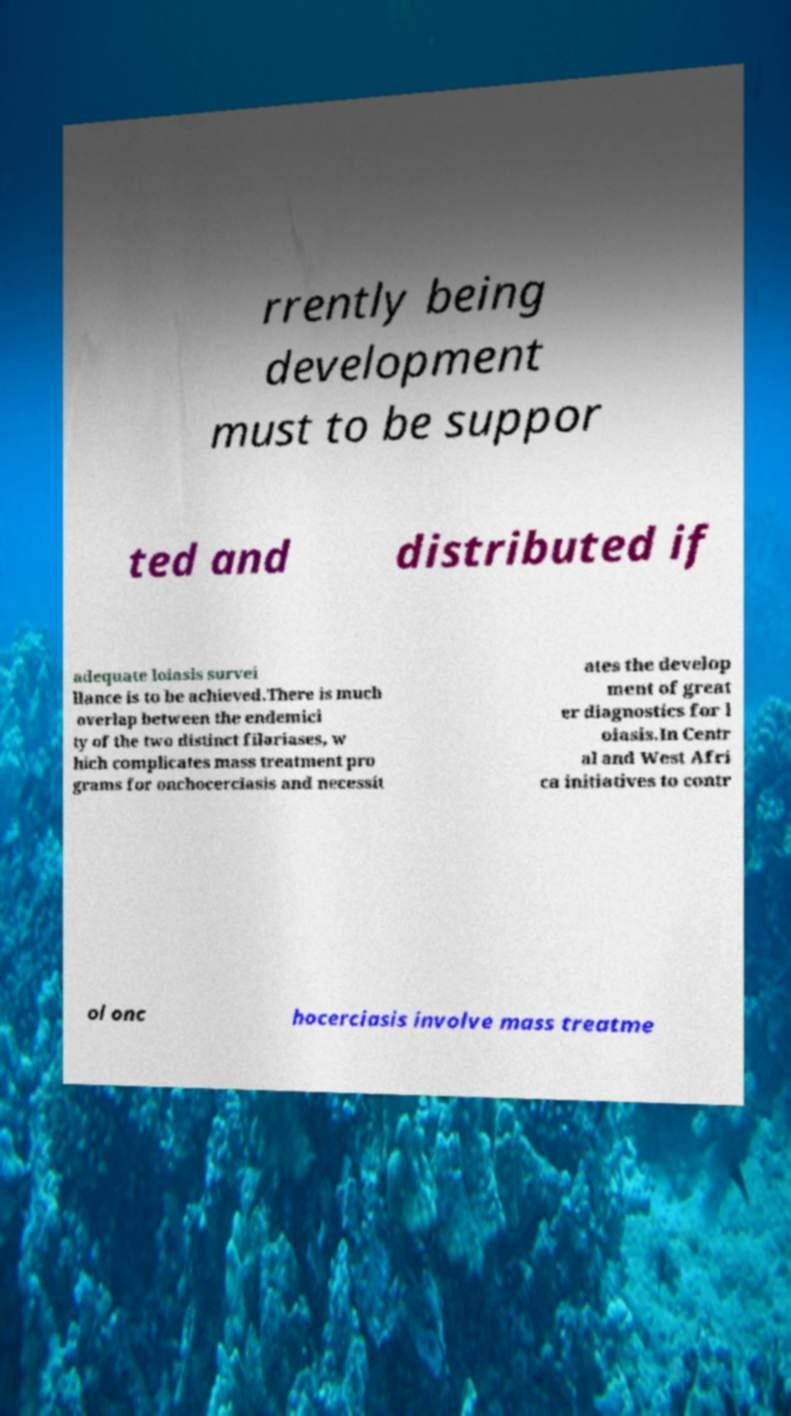Can you accurately transcribe the text from the provided image for me? rrently being development must to be suppor ted and distributed if adequate loiasis survei llance is to be achieved.There is much overlap between the endemici ty of the two distinct filariases, w hich complicates mass treatment pro grams for onchocerciasis and necessit ates the develop ment of great er diagnostics for l oiasis.In Centr al and West Afri ca initiatives to contr ol onc hocerciasis involve mass treatme 